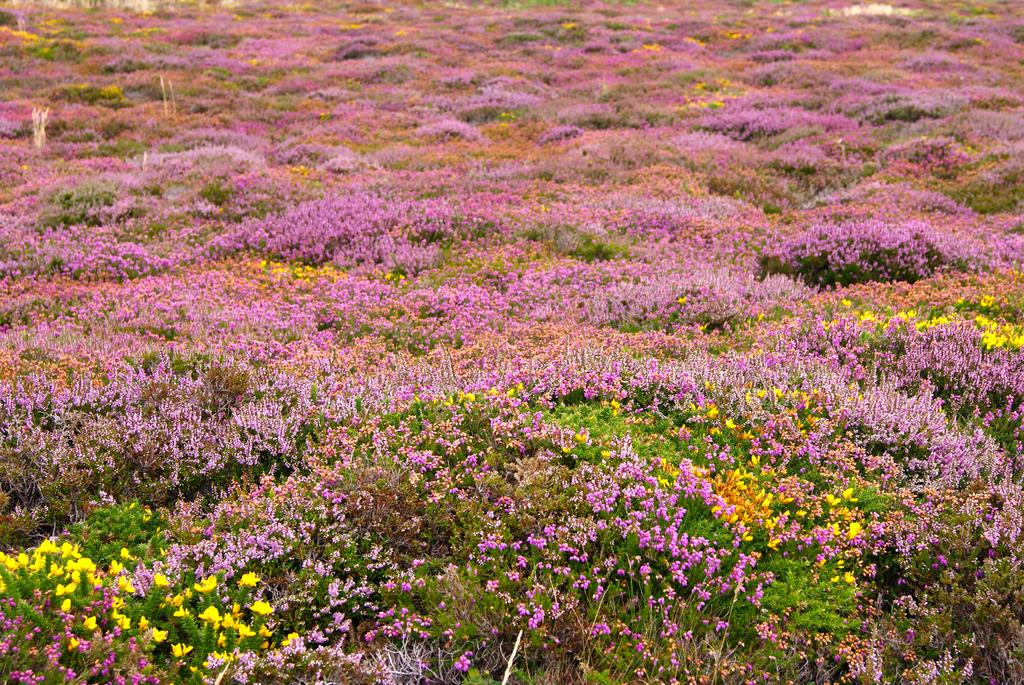What type of living organisms can be seen in the image? Plants can be seen in the image. What specific feature can be observed on the plants? The plants have colorful flowers. What is the growth rate of the plants in the image? The growth rate of the plants cannot be determined from the image alone. Can you tell me the partner of the plant in the image? There is no partner mentioned or depicted in the image. What date is shown on the calendar in the image? There is no calendar present in the image. 